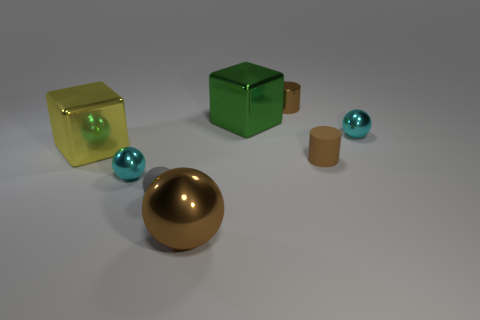How many tiny cylinders have the same color as the large ball?
Give a very brief answer. 2. There is another cylinder that is the same color as the small matte cylinder; what is its material?
Provide a succinct answer. Metal. There is a cylinder to the right of the brown metal object behind the green shiny thing; how big is it?
Your answer should be compact. Small. Is the shape of the cyan shiny object behind the big yellow thing the same as  the tiny brown matte thing?
Provide a succinct answer. No. What material is the other big thing that is the same shape as the yellow shiny object?
Offer a very short reply. Metal. How many things are tiny shiny objects that are in front of the tiny metal cylinder or metal balls on the left side of the big green block?
Your answer should be very brief. 3. Does the small rubber cylinder have the same color as the tiny rubber thing in front of the brown rubber cylinder?
Offer a very short reply. No. What is the shape of the large brown object that is made of the same material as the yellow block?
Provide a succinct answer. Sphere. How many large green rubber balls are there?
Offer a very short reply. 0. How many objects are either small gray matte objects to the left of the big brown thing or large yellow cubes?
Your answer should be very brief. 2. 